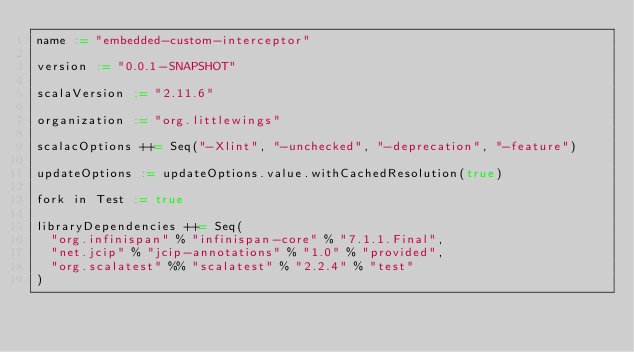Convert code to text. <code><loc_0><loc_0><loc_500><loc_500><_Scala_>name := "embedded-custom-interceptor"

version := "0.0.1-SNAPSHOT"

scalaVersion := "2.11.6"

organization := "org.littlewings"

scalacOptions ++= Seq("-Xlint", "-unchecked", "-deprecation", "-feature")

updateOptions := updateOptions.value.withCachedResolution(true)

fork in Test := true

libraryDependencies ++= Seq(
  "org.infinispan" % "infinispan-core" % "7.1.1.Final",
  "net.jcip" % "jcip-annotations" % "1.0" % "provided",
  "org.scalatest" %% "scalatest" % "2.2.4" % "test"
)
</code> 